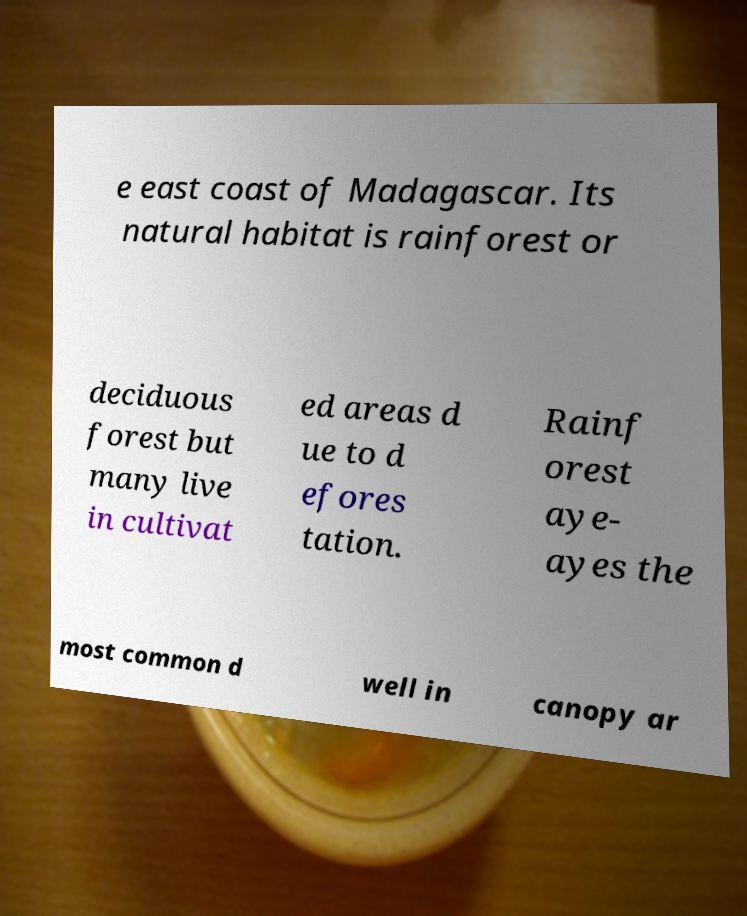What messages or text are displayed in this image? I need them in a readable, typed format. e east coast of Madagascar. Its natural habitat is rainforest or deciduous forest but many live in cultivat ed areas d ue to d efores tation. Rainf orest aye- ayes the most common d well in canopy ar 